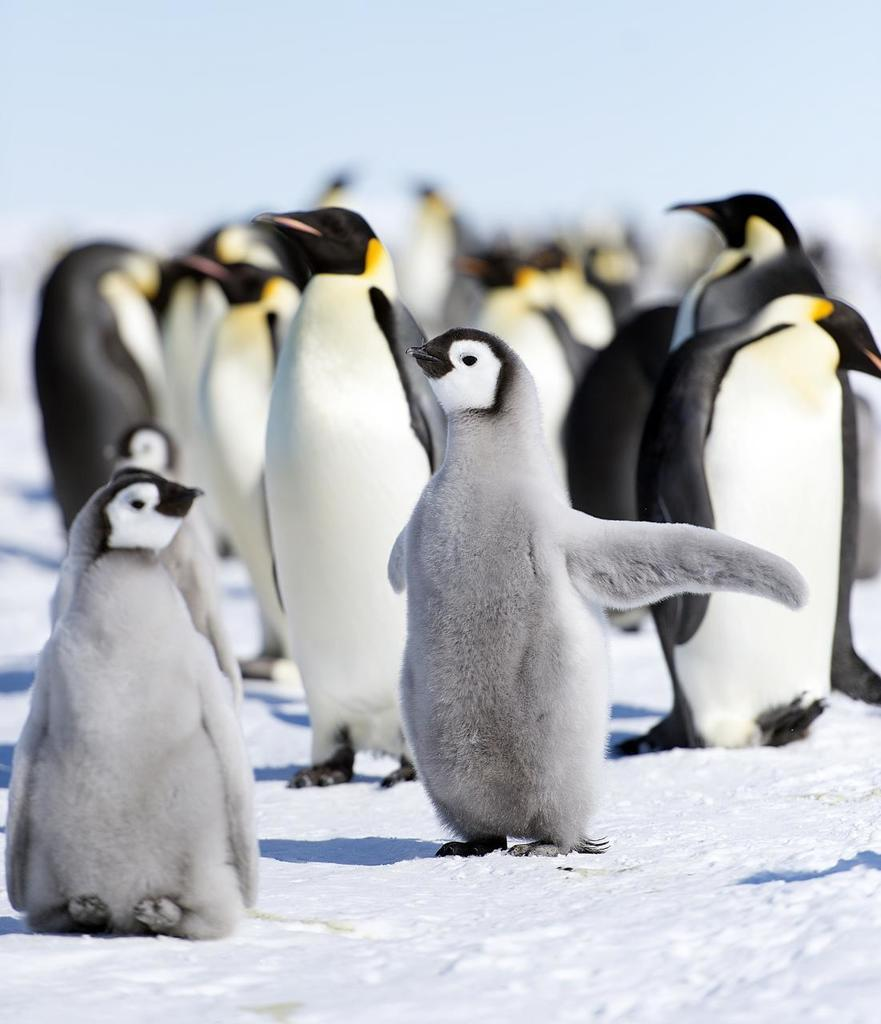What type of animals are in the image? There are penguins in the image. What is the surface on which the penguins are standing? The penguins are on the snow. What colors can be observed on the penguins? The penguins have white and black coloring. What is the color of the background in the image? The background of the image is white. Can you see a rat wearing a collar in the image? There is no rat or collar present in the image; it features penguins on the snow. Do the penguins sneeze in the image? Penguins do not sneeze in the image, as it is a still photograph. 